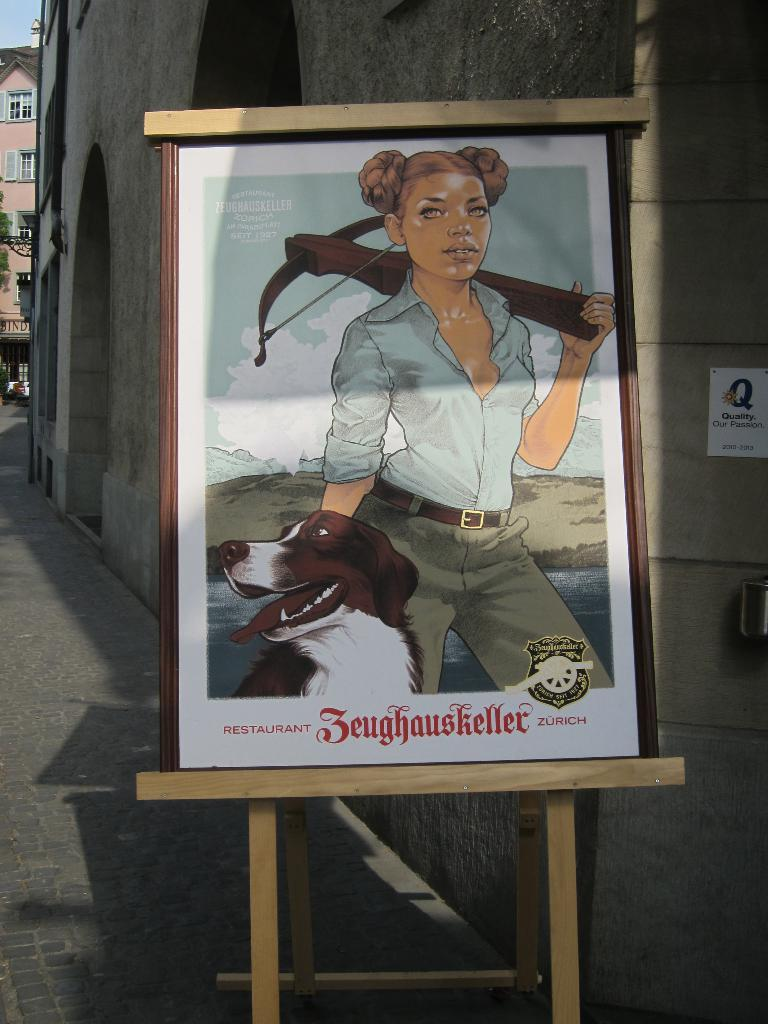What is the main object in the image? There is a board in the image. What is depicted on the board? The board contains a depiction of a person and a dog. What can be seen in the background of the image? There is a wall in the background of the image. What type of agreement is being signed by the person on the board? There is no indication of a person signing an agreement on the board; it only depicts a person and a dog. 